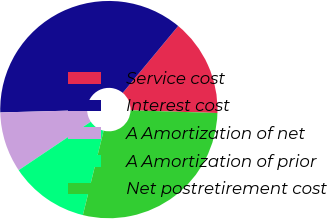Convert chart. <chart><loc_0><loc_0><loc_500><loc_500><pie_chart><fcel>Service cost<fcel>Interest cost<fcel>A Amortization of net<fcel>A Amortization of prior<fcel>Net postretirement cost<nl><fcel>14.48%<fcel>36.44%<fcel>9.0%<fcel>11.74%<fcel>28.34%<nl></chart> 